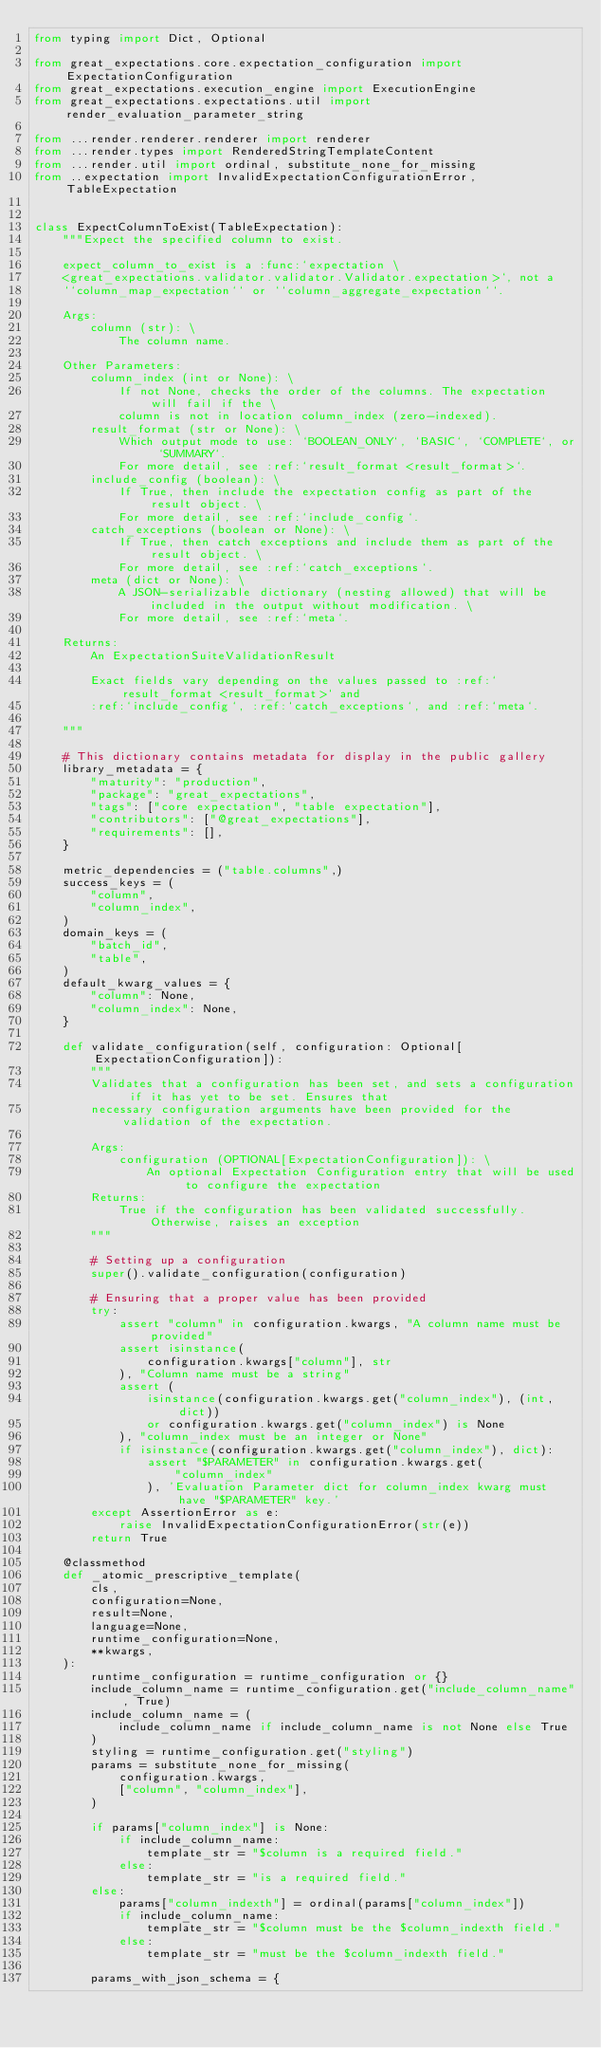<code> <loc_0><loc_0><loc_500><loc_500><_Python_>from typing import Dict, Optional

from great_expectations.core.expectation_configuration import ExpectationConfiguration
from great_expectations.execution_engine import ExecutionEngine
from great_expectations.expectations.util import render_evaluation_parameter_string

from ...render.renderer.renderer import renderer
from ...render.types import RenderedStringTemplateContent
from ...render.util import ordinal, substitute_none_for_missing
from ..expectation import InvalidExpectationConfigurationError, TableExpectation


class ExpectColumnToExist(TableExpectation):
    """Expect the specified column to exist.

    expect_column_to_exist is a :func:`expectation \
    <great_expectations.validator.validator.Validator.expectation>`, not a
    ``column_map_expectation`` or ``column_aggregate_expectation``.

    Args:
        column (str): \
            The column name.

    Other Parameters:
        column_index (int or None): \
            If not None, checks the order of the columns. The expectation will fail if the \
            column is not in location column_index (zero-indexed).
        result_format (str or None): \
            Which output mode to use: `BOOLEAN_ONLY`, `BASIC`, `COMPLETE`, or `SUMMARY`.
            For more detail, see :ref:`result_format <result_format>`.
        include_config (boolean): \
            If True, then include the expectation config as part of the result object. \
            For more detail, see :ref:`include_config`.
        catch_exceptions (boolean or None): \
            If True, then catch exceptions and include them as part of the result object. \
            For more detail, see :ref:`catch_exceptions`.
        meta (dict or None): \
            A JSON-serializable dictionary (nesting allowed) that will be included in the output without modification. \
            For more detail, see :ref:`meta`.

    Returns:
        An ExpectationSuiteValidationResult

        Exact fields vary depending on the values passed to :ref:`result_format <result_format>` and
        :ref:`include_config`, :ref:`catch_exceptions`, and :ref:`meta`.

    """

    # This dictionary contains metadata for display in the public gallery
    library_metadata = {
        "maturity": "production",
        "package": "great_expectations",
        "tags": ["core expectation", "table expectation"],
        "contributors": ["@great_expectations"],
        "requirements": [],
    }

    metric_dependencies = ("table.columns",)
    success_keys = (
        "column",
        "column_index",
    )
    domain_keys = (
        "batch_id",
        "table",
    )
    default_kwarg_values = {
        "column": None,
        "column_index": None,
    }

    def validate_configuration(self, configuration: Optional[ExpectationConfiguration]):
        """
        Validates that a configuration has been set, and sets a configuration if it has yet to be set. Ensures that
        necessary configuration arguments have been provided for the validation of the expectation.

        Args:
            configuration (OPTIONAL[ExpectationConfiguration]): \
                An optional Expectation Configuration entry that will be used to configure the expectation
        Returns:
            True if the configuration has been validated successfully. Otherwise, raises an exception
        """

        # Setting up a configuration
        super().validate_configuration(configuration)

        # Ensuring that a proper value has been provided
        try:
            assert "column" in configuration.kwargs, "A column name must be provided"
            assert isinstance(
                configuration.kwargs["column"], str
            ), "Column name must be a string"
            assert (
                isinstance(configuration.kwargs.get("column_index"), (int, dict))
                or configuration.kwargs.get("column_index") is None
            ), "column_index must be an integer or None"
            if isinstance(configuration.kwargs.get("column_index"), dict):
                assert "$PARAMETER" in configuration.kwargs.get(
                    "column_index"
                ), 'Evaluation Parameter dict for column_index kwarg must have "$PARAMETER" key.'
        except AssertionError as e:
            raise InvalidExpectationConfigurationError(str(e))
        return True

    @classmethod
    def _atomic_prescriptive_template(
        cls,
        configuration=None,
        result=None,
        language=None,
        runtime_configuration=None,
        **kwargs,
    ):
        runtime_configuration = runtime_configuration or {}
        include_column_name = runtime_configuration.get("include_column_name", True)
        include_column_name = (
            include_column_name if include_column_name is not None else True
        )
        styling = runtime_configuration.get("styling")
        params = substitute_none_for_missing(
            configuration.kwargs,
            ["column", "column_index"],
        )

        if params["column_index"] is None:
            if include_column_name:
                template_str = "$column is a required field."
            else:
                template_str = "is a required field."
        else:
            params["column_indexth"] = ordinal(params["column_index"])
            if include_column_name:
                template_str = "$column must be the $column_indexth field."
            else:
                template_str = "must be the $column_indexth field."

        params_with_json_schema = {</code> 